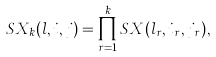<formula> <loc_0><loc_0><loc_500><loc_500>S X _ { k } ( l , i , j ) = \prod _ { r = 1 } ^ { k } S X ( l _ { r } , i _ { r } , j _ { r } ) ,</formula> 